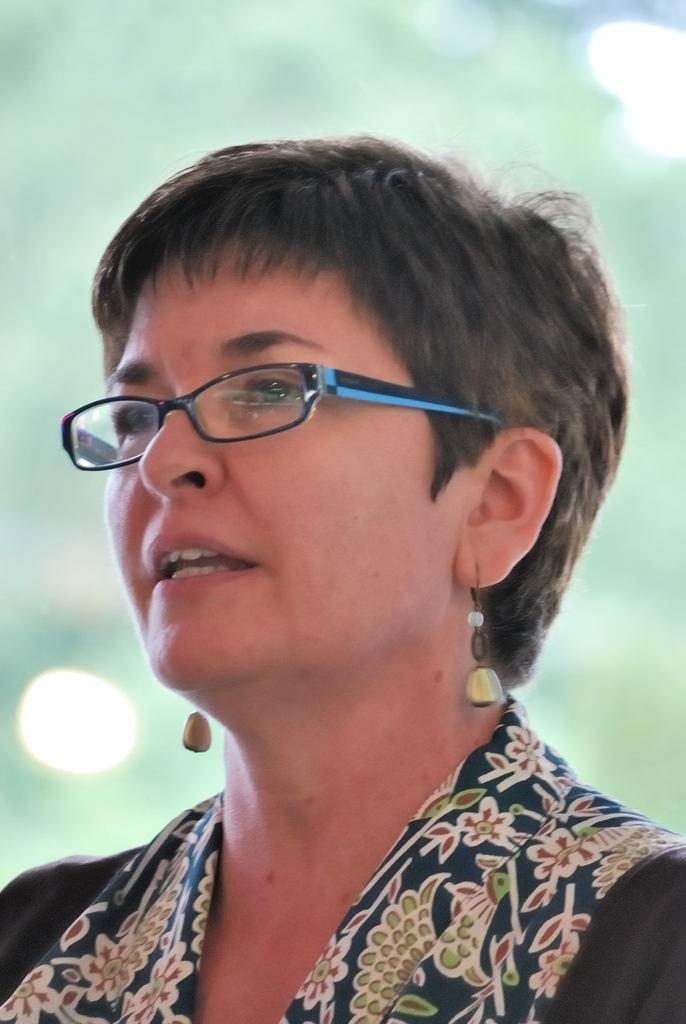Describe this image in one or two sentences. In the picture I can see a woman wearing a dress, earrings and spectacles. The background of the image is blurred. 